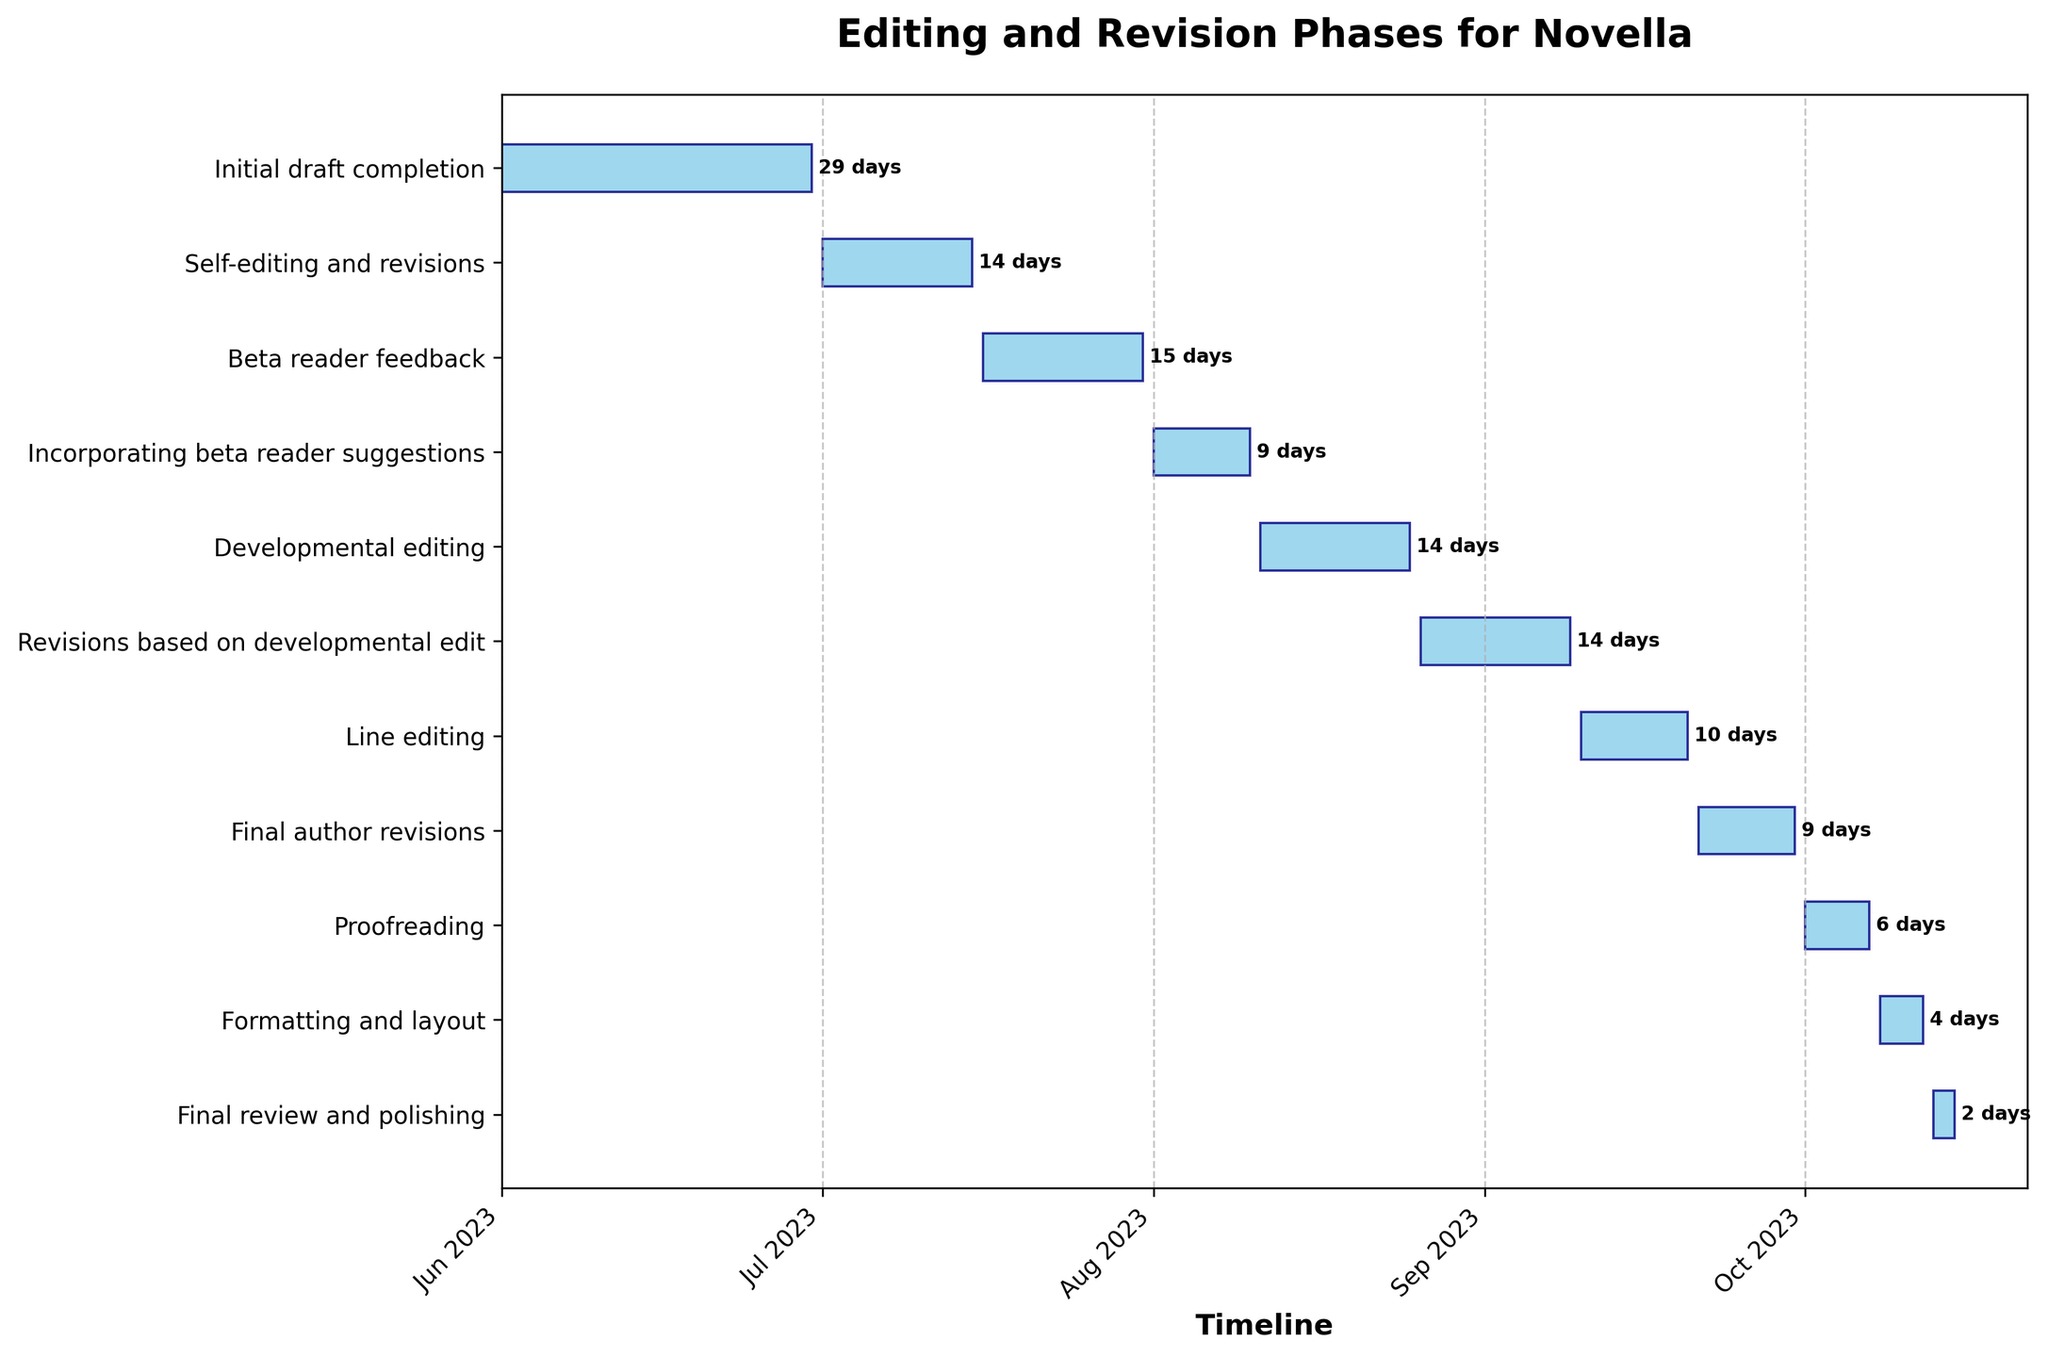What is the title of the Gantt Chart? The title is generally displayed at the top of the chart, and it gives an overview of what the chart represents.
Answer: Editing and Revision Phases for Novella Which task has the shortest duration? By glancing at the lengths of the bars, the shortest one indicates the shortest duration. The task "Final review and polishing" has the shortest bar.
Answer: Final review and polishing When does the "Self-editing and revisions" task start and end? The horizontal bar representing "Self-editing and revisions" starts at the date on the x-axis labeled "Jul 2023" and ends 15 days later.
Answer: 2023-07-01 to 2023-07-15 What is the total duration in days for "Beta reader feedback" and "Incorporating beta reader suggestions"? From the chart, "Beta reader feedback" lasts 16 days, and "Incorporating beta reader suggestions" lasts 10 days. Summing these gives 16 + 10.
Answer: 26 days Which two tasks have an equal duration? By comparing the lengths of the bars visually, "Self-editing and revisions" and "Developmental editing" both last 15 days.
Answer: Self-editing and revisions, Developmental editing What period covers the "Developmental editing" phase? The bar for "Developmental editing" starts in mid-August and lasts for 15 days. The caption or axis can be used to determine the exact dates.
Answer: 2023-08-11 to 2023-08-25 Which task immediately follows "Final author revisions"? By checking the chronological order of tasks and matching end dates to start dates, the task following "Final author revisions" is "Proofreading."
Answer: Proofreading Is the "Line editing" phase longer than the "Final author revisions" phase? "Line editing" lasts 11 days, and "Final author revisions" lasts 10 days. Comparing these durations, line editing is longer by 1 day.
Answer: Yes How many tasks span into October? By checking the x-axis against the bars, the tasks "Proofreading," "Formatting and layout," and "Final review and polishing" span into October.
Answer: 3 tasks When does the "Proofreading" task end? The task "Proofreading" is plotted on the x-axis and finishes 7 days after its start date, indicating it ends at the beginning of October.
Answer: 2023-10-07 